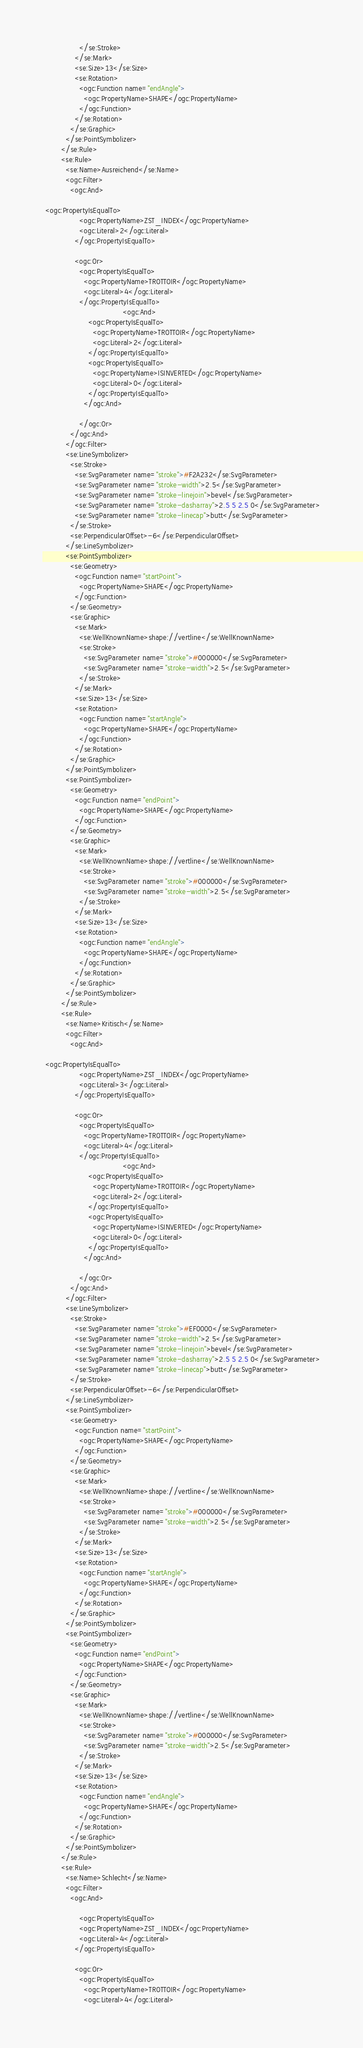Convert code to text. <code><loc_0><loc_0><loc_500><loc_500><_Scheme_>                </se:Stroke>
              </se:Mark>
              <se:Size>13</se:Size>
              <se:Rotation>
                <ogc:Function name="endAngle">
                  <ogc:PropertyName>SHAPE</ogc:PropertyName>
                </ogc:Function>
              </se:Rotation>
            </se:Graphic>
          </se:PointSymbolizer>
        </se:Rule>
        <se:Rule>
          <se:Name>Ausreichend</se:Name>
          <ogc:Filter>
            <ogc:And>

 <ogc:PropertyIsEqualTo>
                <ogc:PropertyName>ZST_INDEX</ogc:PropertyName>
                <ogc:Literal>2</ogc:Literal>
              </ogc:PropertyIsEqualTo>
              
              <ogc:Or>
                <ogc:PropertyIsEqualTo>
                  <ogc:PropertyName>TROTTOIR</ogc:PropertyName>
                  <ogc:Literal>4</ogc:Literal>
                </ogc:PropertyIsEqualTo>
                                   <ogc:And>
                    <ogc:PropertyIsEqualTo>
                      <ogc:PropertyName>TROTTOIR</ogc:PropertyName>
                      <ogc:Literal>2</ogc:Literal>
                    </ogc:PropertyIsEqualTo>
                    <ogc:PropertyIsEqualTo>
                      <ogc:PropertyName>ISINVERTED</ogc:PropertyName>
                      <ogc:Literal>0</ogc:Literal>
                    </ogc:PropertyIsEqualTo>
                  </ogc:And>
                  
                </ogc:Or>
            </ogc:And>
          </ogc:Filter>
          <se:LineSymbolizer>
            <se:Stroke>
              <se:SvgParameter name="stroke">#F2A232</se:SvgParameter>
              <se:SvgParameter name="stroke-width">2.5</se:SvgParameter>
              <se:SvgParameter name="stroke-linejoin">bevel</se:SvgParameter>
              <se:SvgParameter name="stroke-dasharray">2.5 5 2.5 0</se:SvgParameter>
              <se:SvgParameter name="stroke-linecap">butt</se:SvgParameter>
            </se:Stroke>
            <se:PerpendicularOffset>-6</se:PerpendicularOffset>
          </se:LineSymbolizer>
          <se:PointSymbolizer>
            <se:Geometry>
              <ogc:Function name="startPoint">
                <ogc:PropertyName>SHAPE</ogc:PropertyName>
              </ogc:Function>
            </se:Geometry>
            <se:Graphic>
              <se:Mark>
                <se:WellKnownName>shape://vertline</se:WellKnownName>
                <se:Stroke>
                  <se:SvgParameter name="stroke">#000000</se:SvgParameter>
                  <se:SvgParameter name="stroke-width">2.5</se:SvgParameter>
                </se:Stroke>
              </se:Mark>
              <se:Size>13</se:Size>
              <se:Rotation>
                <ogc:Function name="startAngle">
                  <ogc:PropertyName>SHAPE</ogc:PropertyName>
                </ogc:Function>
              </se:Rotation>
            </se:Graphic>
          </se:PointSymbolizer>
          <se:PointSymbolizer>
            <se:Geometry>
              <ogc:Function name="endPoint">
                <ogc:PropertyName>SHAPE</ogc:PropertyName>
              </ogc:Function>
            </se:Geometry>
            <se:Graphic>
              <se:Mark>
                <se:WellKnownName>shape://vertline</se:WellKnownName>
                <se:Stroke>
                  <se:SvgParameter name="stroke">#000000</se:SvgParameter>
                  <se:SvgParameter name="stroke-width">2.5</se:SvgParameter>
                </se:Stroke>
              </se:Mark>
              <se:Size>13</se:Size>
              <se:Rotation>
                <ogc:Function name="endAngle">
                  <ogc:PropertyName>SHAPE</ogc:PropertyName>
                </ogc:Function>
              </se:Rotation>
            </se:Graphic>
          </se:PointSymbolizer>
        </se:Rule>
        <se:Rule>
          <se:Name>Kritisch</se:Name>
          <ogc:Filter>
            <ogc:And>

 <ogc:PropertyIsEqualTo>
                <ogc:PropertyName>ZST_INDEX</ogc:PropertyName>
                <ogc:Literal>3</ogc:Literal>
              </ogc:PropertyIsEqualTo>
              
              <ogc:Or>
                <ogc:PropertyIsEqualTo>
                  <ogc:PropertyName>TROTTOIR</ogc:PropertyName>
                  <ogc:Literal>4</ogc:Literal>
                </ogc:PropertyIsEqualTo>
                                   <ogc:And>
                    <ogc:PropertyIsEqualTo>
                      <ogc:PropertyName>TROTTOIR</ogc:PropertyName>
                      <ogc:Literal>2</ogc:Literal>
                    </ogc:PropertyIsEqualTo>
                    <ogc:PropertyIsEqualTo>
                      <ogc:PropertyName>ISINVERTED</ogc:PropertyName>
                      <ogc:Literal>0</ogc:Literal>
                    </ogc:PropertyIsEqualTo>
                  </ogc:And>
                  
                </ogc:Or>
            </ogc:And>
          </ogc:Filter>
          <se:LineSymbolizer>
            <se:Stroke>
              <se:SvgParameter name="stroke">#EF0000</se:SvgParameter>
              <se:SvgParameter name="stroke-width">2.5</se:SvgParameter>
              <se:SvgParameter name="stroke-linejoin">bevel</se:SvgParameter>
              <se:SvgParameter name="stroke-dasharray">2.5 5 2.5 0</se:SvgParameter>
              <se:SvgParameter name="stroke-linecap">butt</se:SvgParameter>
            </se:Stroke>
            <se:PerpendicularOffset>-6</se:PerpendicularOffset>
          </se:LineSymbolizer>
          <se:PointSymbolizer>
            <se:Geometry>
              <ogc:Function name="startPoint">
                <ogc:PropertyName>SHAPE</ogc:PropertyName>
              </ogc:Function>
            </se:Geometry>
            <se:Graphic>
              <se:Mark>
                <se:WellKnownName>shape://vertline</se:WellKnownName>
                <se:Stroke>
                  <se:SvgParameter name="stroke">#000000</se:SvgParameter>
                  <se:SvgParameter name="stroke-width">2.5</se:SvgParameter>
                </se:Stroke>
              </se:Mark>
              <se:Size>13</se:Size>
              <se:Rotation>
                <ogc:Function name="startAngle">
                  <ogc:PropertyName>SHAPE</ogc:PropertyName>
                </ogc:Function>
              </se:Rotation>
            </se:Graphic>
          </se:PointSymbolizer>
          <se:PointSymbolizer>
            <se:Geometry>
              <ogc:Function name="endPoint">
                <ogc:PropertyName>SHAPE</ogc:PropertyName>
              </ogc:Function>
            </se:Geometry>
            <se:Graphic>
              <se:Mark>
                <se:WellKnownName>shape://vertline</se:WellKnownName>
                <se:Stroke>
                  <se:SvgParameter name="stroke">#000000</se:SvgParameter>
                  <se:SvgParameter name="stroke-width">2.5</se:SvgParameter>
                </se:Stroke>
              </se:Mark>
              <se:Size>13</se:Size>
              <se:Rotation>
                <ogc:Function name="endAngle">
                  <ogc:PropertyName>SHAPE</ogc:PropertyName>
                </ogc:Function>
              </se:Rotation>
            </se:Graphic>
          </se:PointSymbolizer>
        </se:Rule>
        <se:Rule>
          <se:Name>Schlecht</se:Name>
          <ogc:Filter>
            <ogc:And>

                <ogc:PropertyIsEqualTo>
                <ogc:PropertyName>ZST_INDEX</ogc:PropertyName>
                <ogc:Literal>4</ogc:Literal>
              </ogc:PropertyIsEqualTo>
              
              <ogc:Or>
                <ogc:PropertyIsEqualTo>
                  <ogc:PropertyName>TROTTOIR</ogc:PropertyName>
                  <ogc:Literal>4</ogc:Literal></code> 